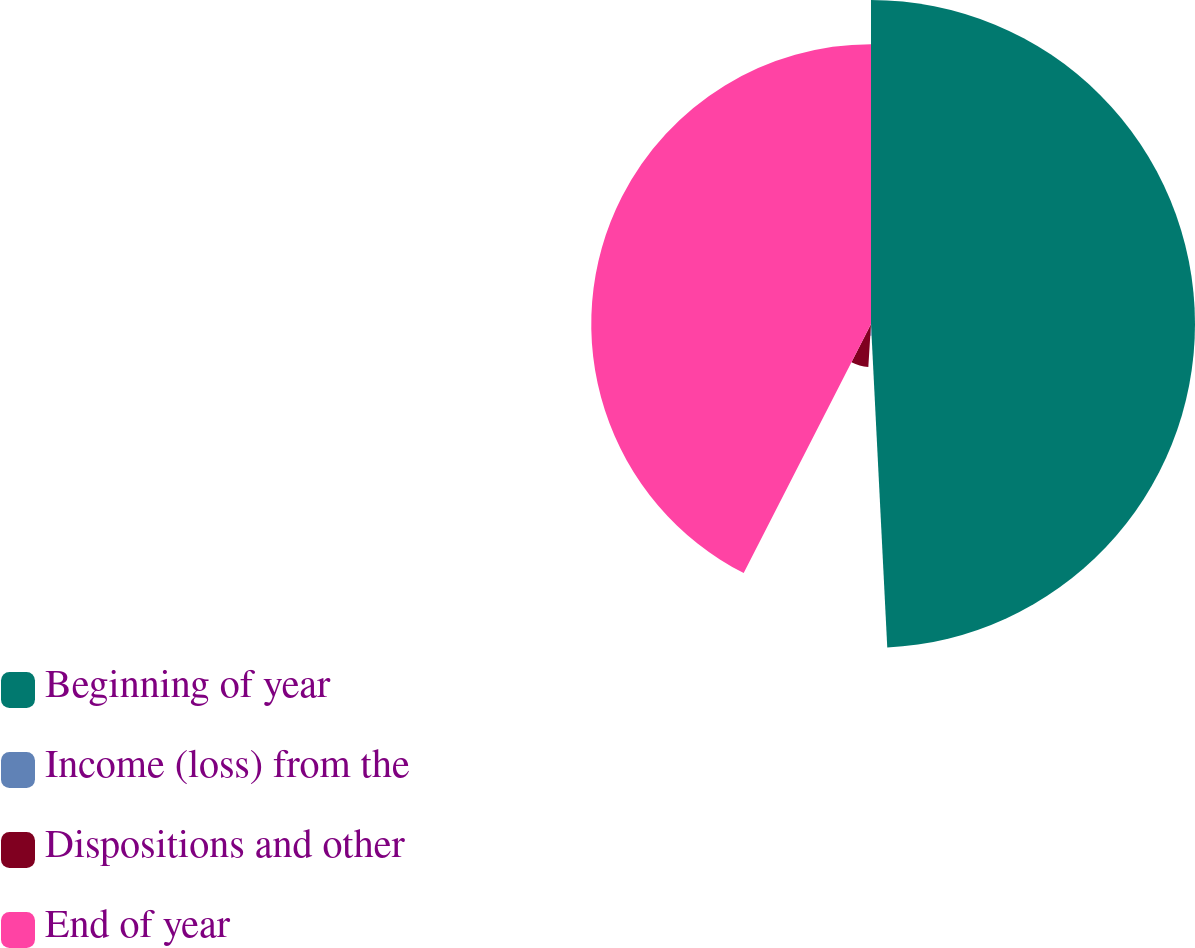Convert chart. <chart><loc_0><loc_0><loc_500><loc_500><pie_chart><fcel>Beginning of year<fcel>Income (loss) from the<fcel>Dispositions and other<fcel>End of year<nl><fcel>49.2%<fcel>1.79%<fcel>6.53%<fcel>42.48%<nl></chart> 